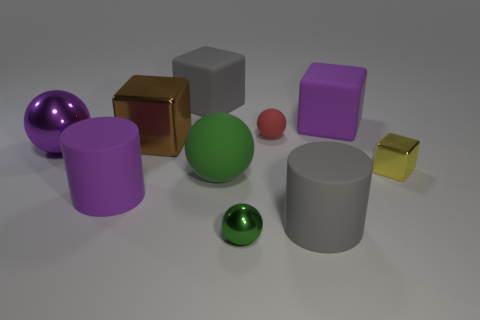Subtract 1 blocks. How many blocks are left? 3 Subtract all cylinders. How many objects are left? 8 Add 8 red matte spheres. How many red matte spheres are left? 9 Add 4 gray metallic spheres. How many gray metallic spheres exist? 4 Subtract 0 gray spheres. How many objects are left? 10 Subtract all tiny purple rubber balls. Subtract all red things. How many objects are left? 9 